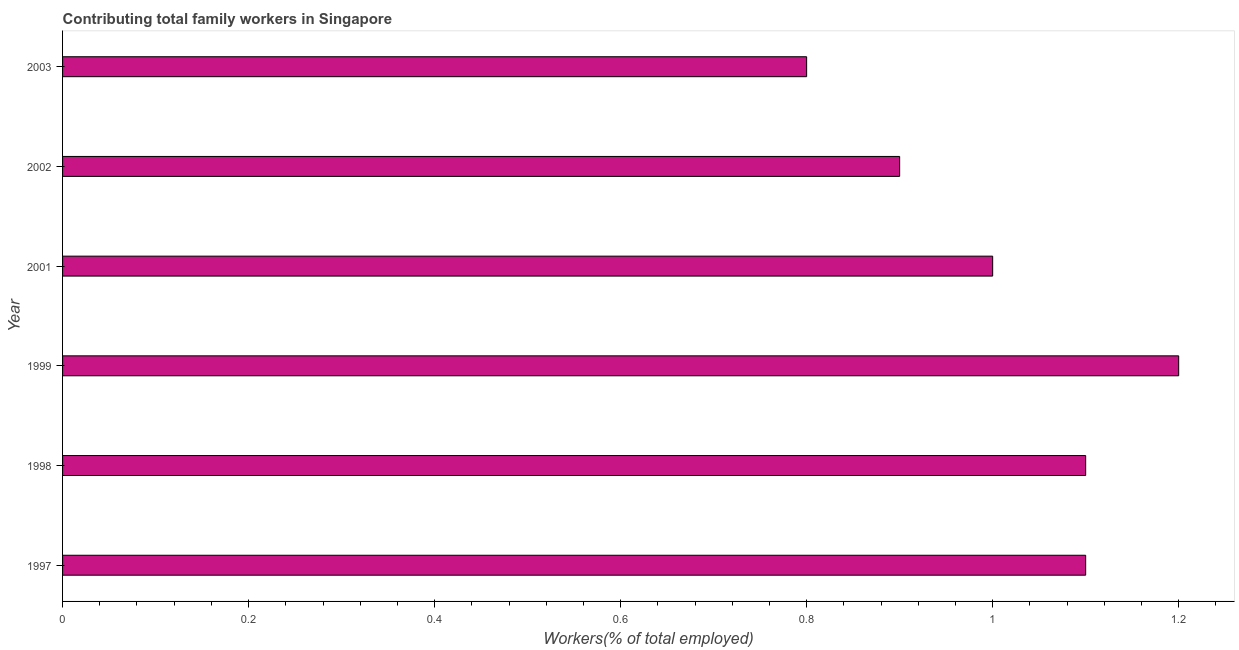Does the graph contain grids?
Your answer should be very brief. No. What is the title of the graph?
Offer a terse response. Contributing total family workers in Singapore. What is the label or title of the X-axis?
Ensure brevity in your answer.  Workers(% of total employed). What is the label or title of the Y-axis?
Make the answer very short. Year. What is the contributing family workers in 1999?
Your answer should be very brief. 1.2. Across all years, what is the maximum contributing family workers?
Your response must be concise. 1.2. Across all years, what is the minimum contributing family workers?
Your answer should be very brief. 0.8. In which year was the contributing family workers minimum?
Your response must be concise. 2003. What is the sum of the contributing family workers?
Your response must be concise. 6.1. What is the median contributing family workers?
Keep it short and to the point. 1.05. What is the ratio of the contributing family workers in 1997 to that in 1999?
Offer a terse response. 0.92. Is the contributing family workers in 1998 less than that in 2003?
Keep it short and to the point. No. Is the difference between the contributing family workers in 2002 and 2003 greater than the difference between any two years?
Give a very brief answer. No. Are all the bars in the graph horizontal?
Provide a short and direct response. Yes. Are the values on the major ticks of X-axis written in scientific E-notation?
Ensure brevity in your answer.  No. What is the Workers(% of total employed) in 1997?
Your response must be concise. 1.1. What is the Workers(% of total employed) in 1998?
Your answer should be very brief. 1.1. What is the Workers(% of total employed) in 1999?
Ensure brevity in your answer.  1.2. What is the Workers(% of total employed) in 2001?
Provide a succinct answer. 1. What is the Workers(% of total employed) of 2002?
Keep it short and to the point. 0.9. What is the Workers(% of total employed) in 2003?
Offer a terse response. 0.8. What is the difference between the Workers(% of total employed) in 1997 and 1998?
Provide a short and direct response. 0. What is the difference between the Workers(% of total employed) in 1997 and 2001?
Provide a succinct answer. 0.1. What is the difference between the Workers(% of total employed) in 1997 and 2003?
Provide a short and direct response. 0.3. What is the difference between the Workers(% of total employed) in 1998 and 2002?
Ensure brevity in your answer.  0.2. What is the difference between the Workers(% of total employed) in 1998 and 2003?
Keep it short and to the point. 0.3. What is the difference between the Workers(% of total employed) in 1999 and 2001?
Provide a succinct answer. 0.2. What is the difference between the Workers(% of total employed) in 1999 and 2003?
Provide a short and direct response. 0.4. What is the difference between the Workers(% of total employed) in 2001 and 2003?
Offer a terse response. 0.2. What is the ratio of the Workers(% of total employed) in 1997 to that in 1999?
Your answer should be compact. 0.92. What is the ratio of the Workers(% of total employed) in 1997 to that in 2001?
Make the answer very short. 1.1. What is the ratio of the Workers(% of total employed) in 1997 to that in 2002?
Give a very brief answer. 1.22. What is the ratio of the Workers(% of total employed) in 1997 to that in 2003?
Give a very brief answer. 1.38. What is the ratio of the Workers(% of total employed) in 1998 to that in 1999?
Provide a short and direct response. 0.92. What is the ratio of the Workers(% of total employed) in 1998 to that in 2001?
Provide a short and direct response. 1.1. What is the ratio of the Workers(% of total employed) in 1998 to that in 2002?
Your response must be concise. 1.22. What is the ratio of the Workers(% of total employed) in 1998 to that in 2003?
Keep it short and to the point. 1.38. What is the ratio of the Workers(% of total employed) in 1999 to that in 2002?
Offer a very short reply. 1.33. What is the ratio of the Workers(% of total employed) in 1999 to that in 2003?
Provide a short and direct response. 1.5. What is the ratio of the Workers(% of total employed) in 2001 to that in 2002?
Your answer should be very brief. 1.11. 